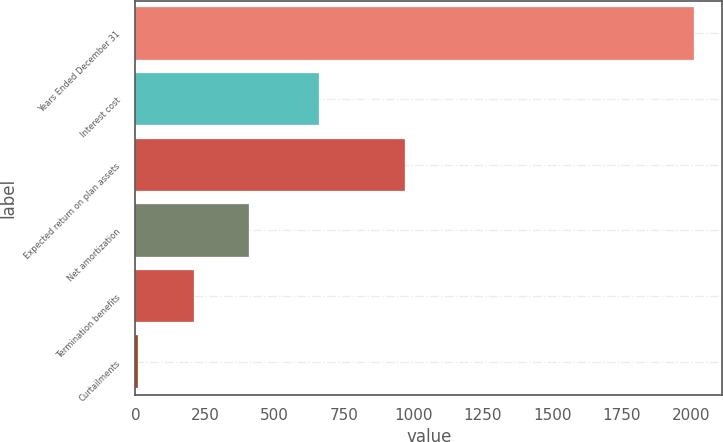<chart> <loc_0><loc_0><loc_500><loc_500><bar_chart><fcel>Years Ended December 31<fcel>Interest cost<fcel>Expected return on plan assets<fcel>Net amortization<fcel>Termination benefits<fcel>Curtailments<nl><fcel>2012<fcel>661<fcel>970<fcel>410.4<fcel>210.2<fcel>10<nl></chart> 